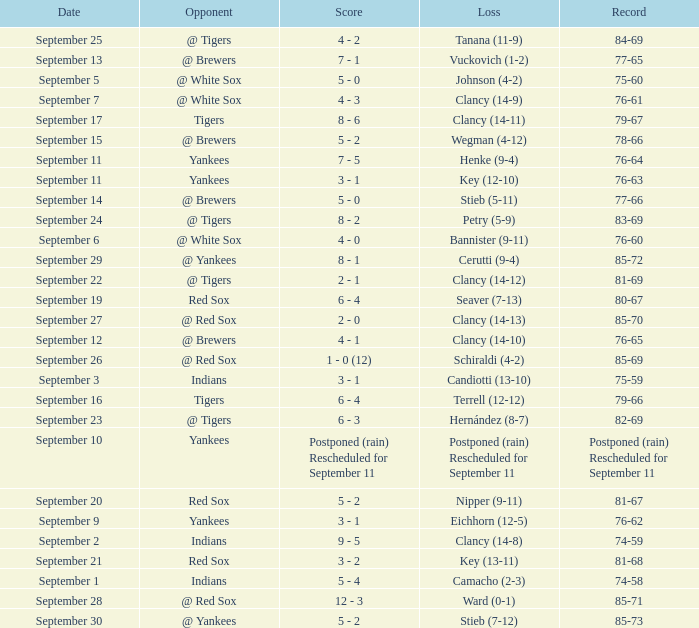What was the date of the game when their record was 84-69? September 25. 